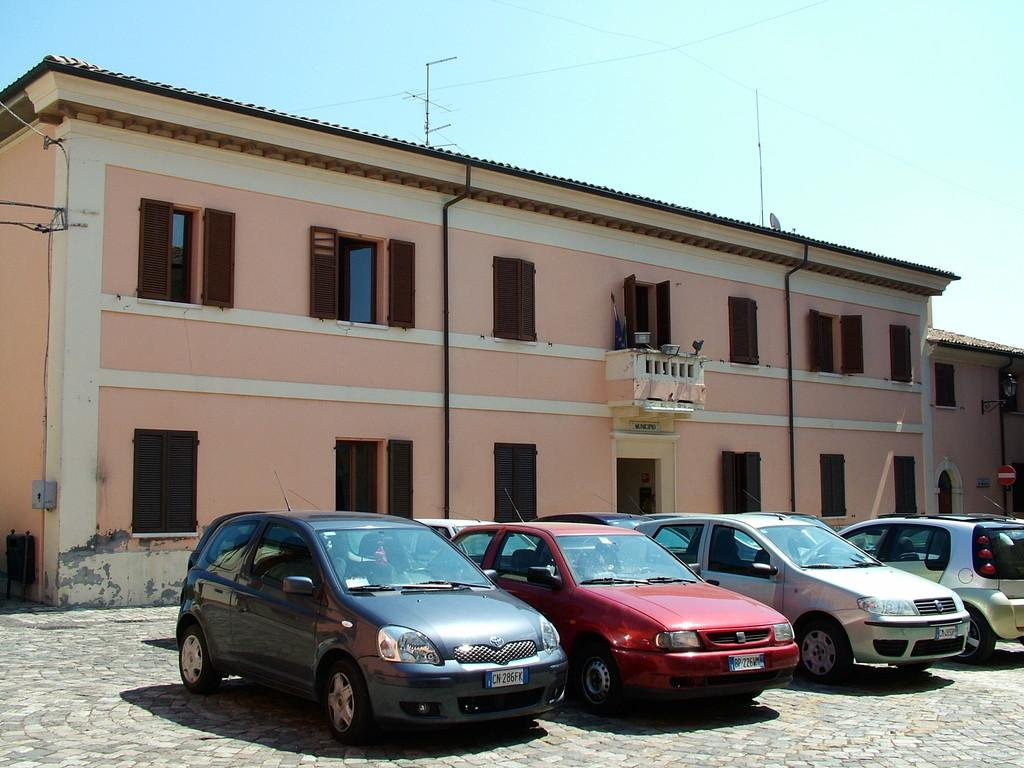What can be seen in the image regarding vehicles? There are cars parked in a straight line in the image. What type of structure is visible in the background? There is a building in the background of the image. How would you describe the weather based on the image? The sky is clear in the image, suggesting good weather. How many laborers are working on the angle of the building in the image? There is no laborer present in the image, and the angle of the building is not mentioned. 